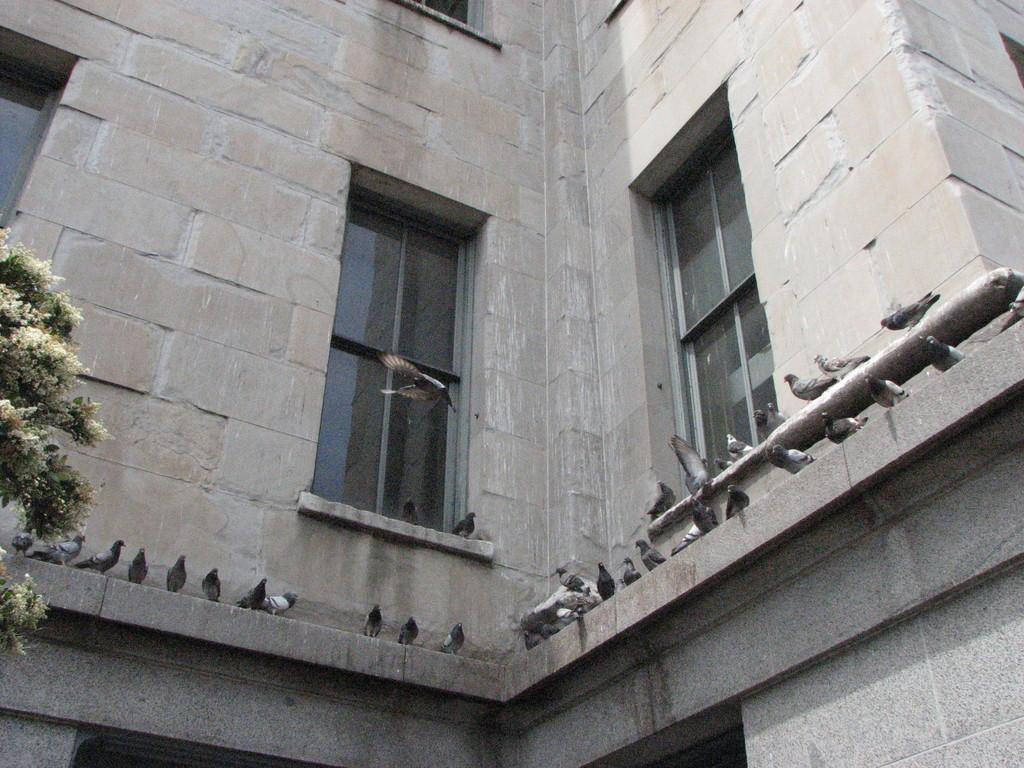Describe this image in one or two sentences. In this picture we can see a bird is flying in the air and some birds are on the wall. Behind the birds there is a building with windows. On the left side of the birds there is a tree. 